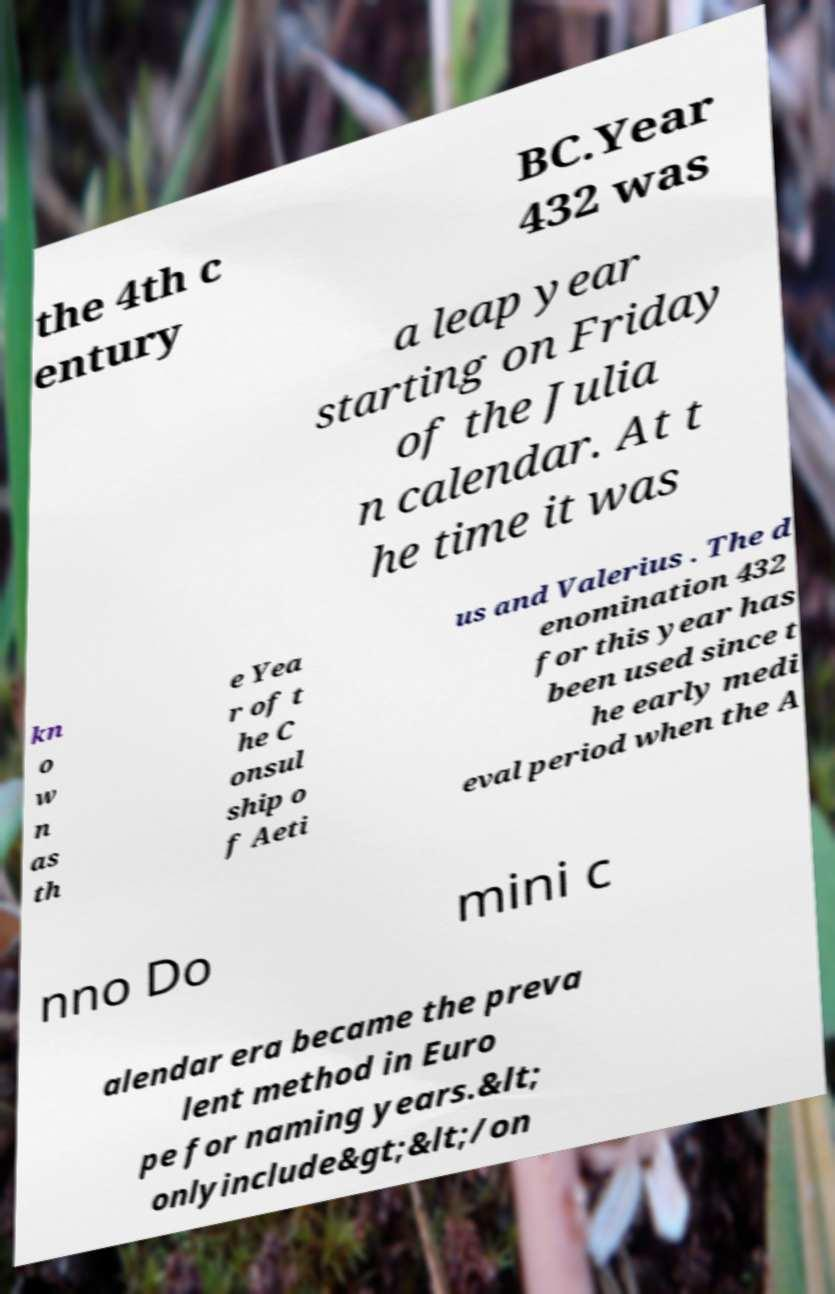For documentation purposes, I need the text within this image transcribed. Could you provide that? the 4th c entury BC.Year 432 was a leap year starting on Friday of the Julia n calendar. At t he time it was kn o w n as th e Yea r of t he C onsul ship o f Aeti us and Valerius . The d enomination 432 for this year has been used since t he early medi eval period when the A nno Do mini c alendar era became the preva lent method in Euro pe for naming years.&lt; onlyinclude&gt;&lt;/on 